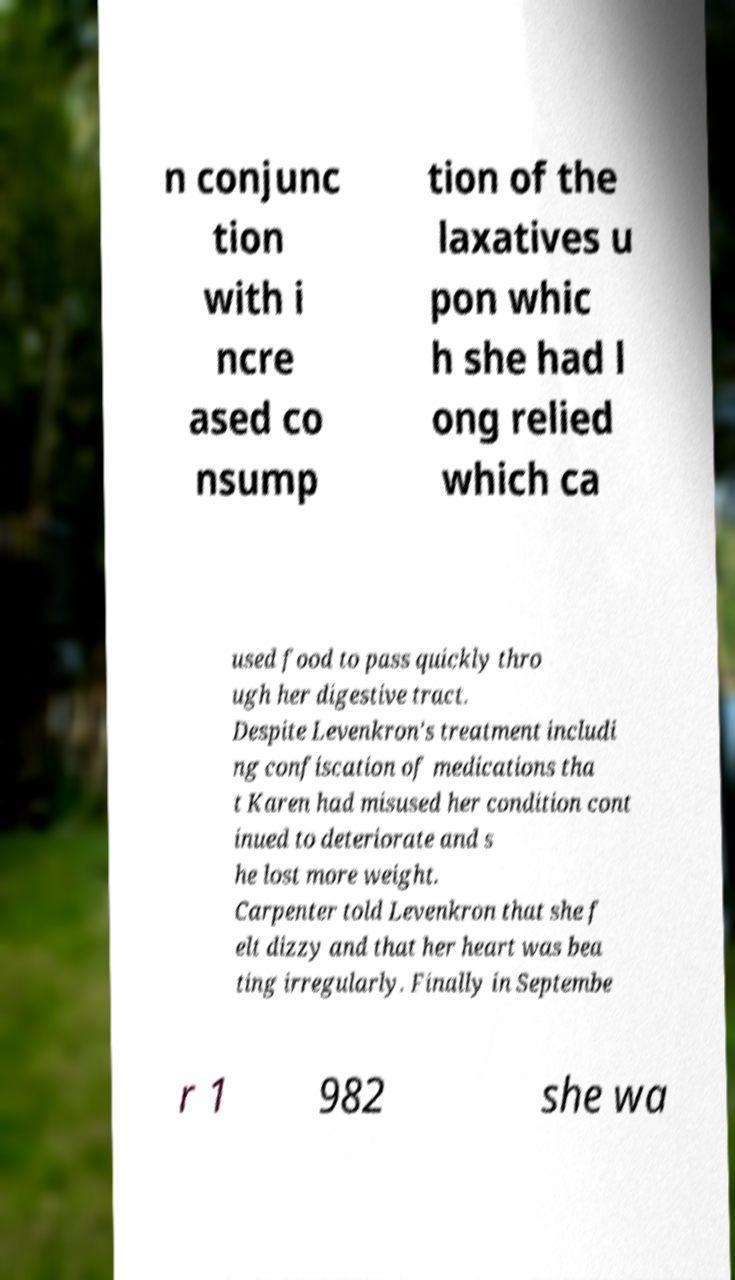For documentation purposes, I need the text within this image transcribed. Could you provide that? n conjunc tion with i ncre ased co nsump tion of the laxatives u pon whic h she had l ong relied which ca used food to pass quickly thro ugh her digestive tract. Despite Levenkron's treatment includi ng confiscation of medications tha t Karen had misused her condition cont inued to deteriorate and s he lost more weight. Carpenter told Levenkron that she f elt dizzy and that her heart was bea ting irregularly. Finally in Septembe r 1 982 she wa 